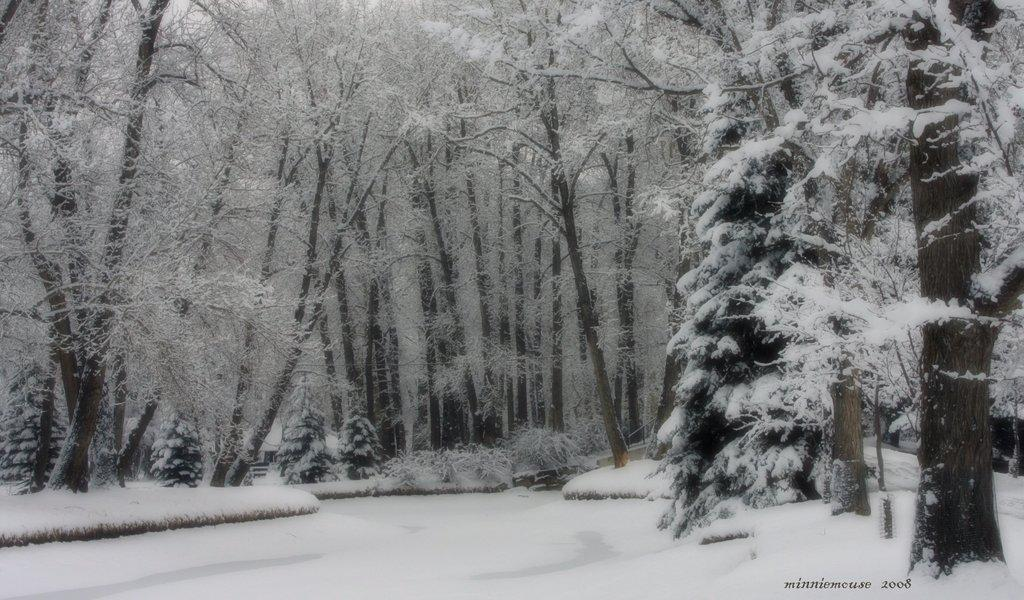What is the primary weather condition depicted in the image? There is snow in the image. What type of natural elements can be seen in the image? There are trees in the image. Where is the text located in the image? The text is in the bottom right-hand corner of the image. Can you see a plane flying over the snow in the image? There is no plane visible in the image; it only features snow and trees. What process is being carried out in the image? The image does not depict a specific process; it simply shows snow and trees. 